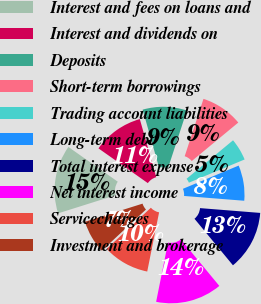Convert chart. <chart><loc_0><loc_0><loc_500><loc_500><pie_chart><fcel>Interest and fees on loans and<fcel>Interest and dividends on<fcel>Deposits<fcel>Short-term borrowings<fcel>Trading account liabilities<fcel>Long-term debt<fcel>Total interest expense<fcel>Net interest income<fcel>Servicecharges<fcel>Investment and brokerage<nl><fcel>14.62%<fcel>10.85%<fcel>9.43%<fcel>8.96%<fcel>4.72%<fcel>7.55%<fcel>12.74%<fcel>14.15%<fcel>9.91%<fcel>7.08%<nl></chart> 